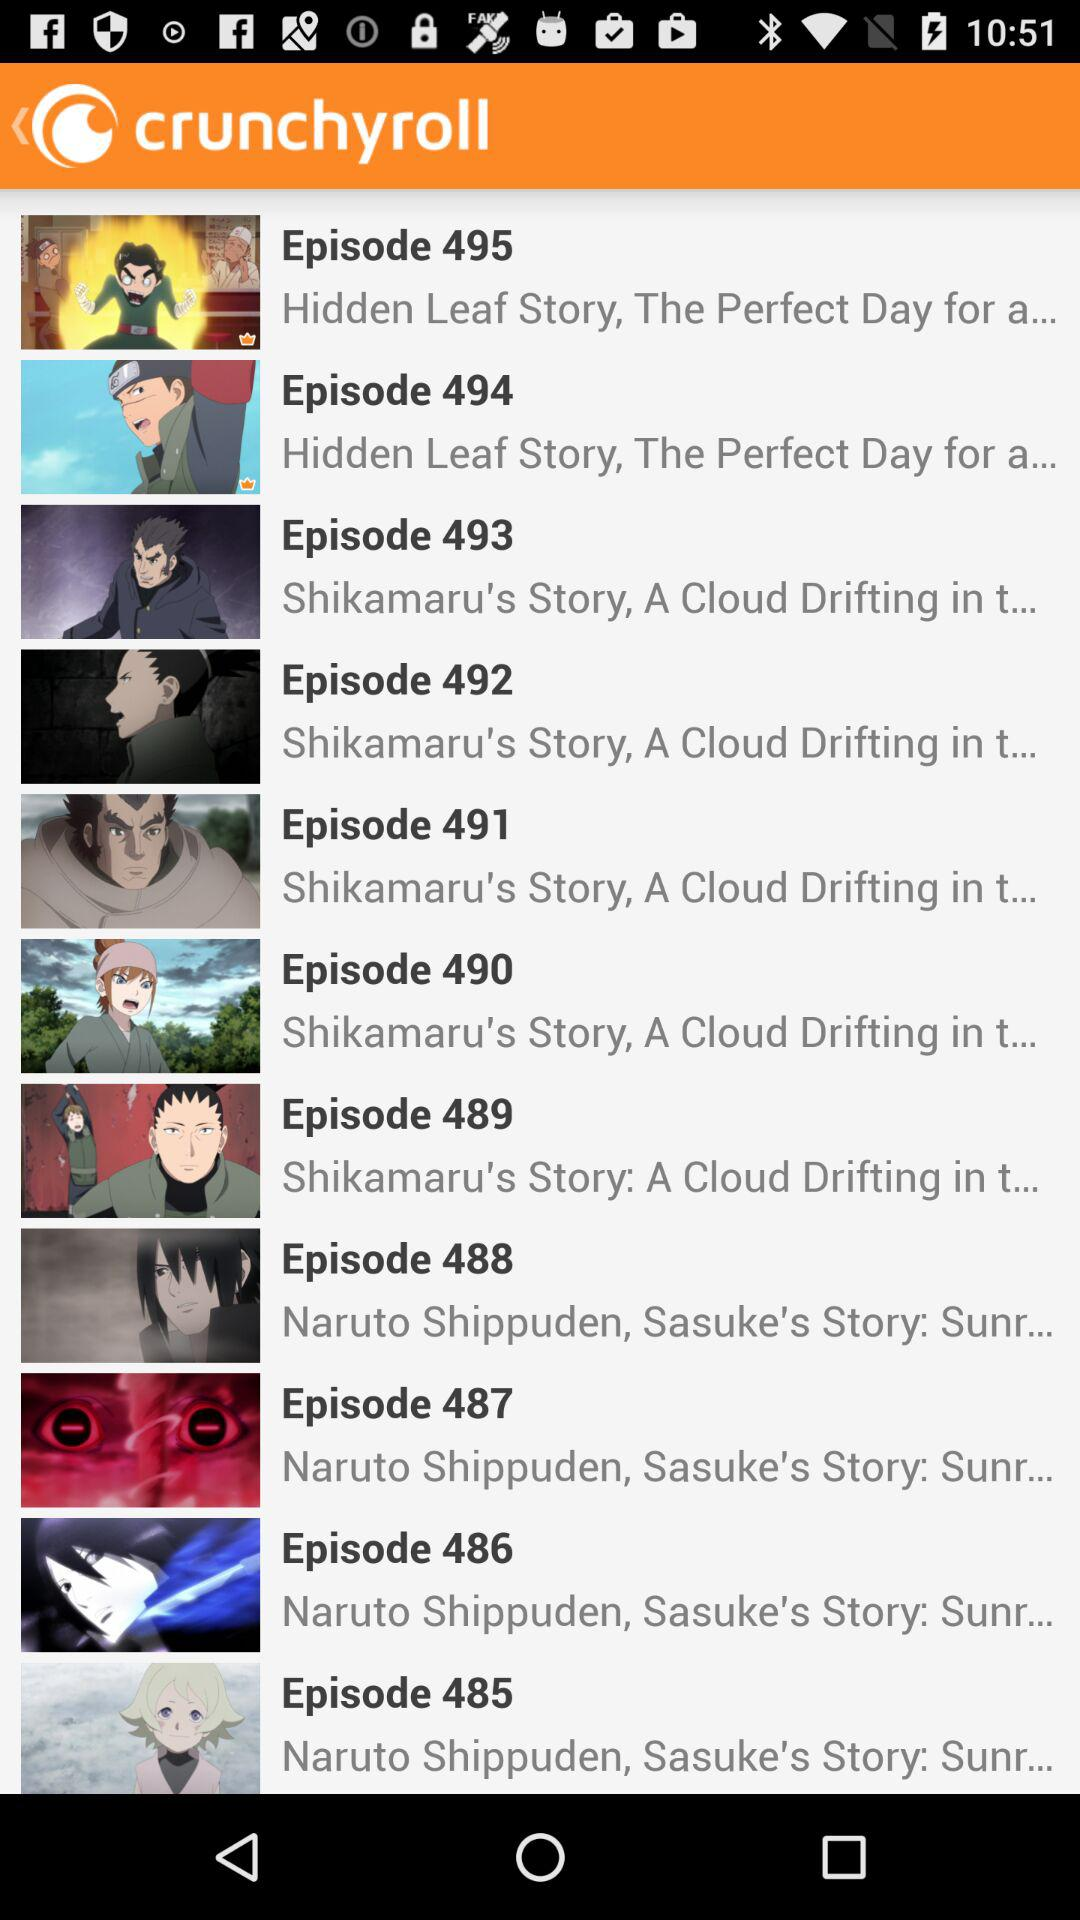What is the name of episode 490? The name of episode 490 is "Shikamaru's Story, A Cloud Drifting in t...". 